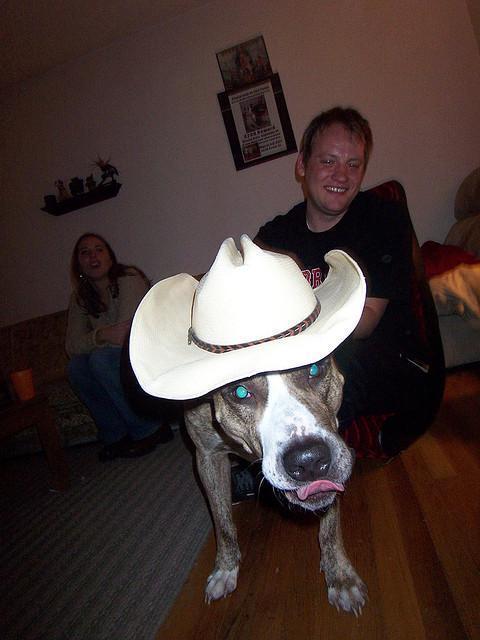How many people are in the picture?
Give a very brief answer. 2. 